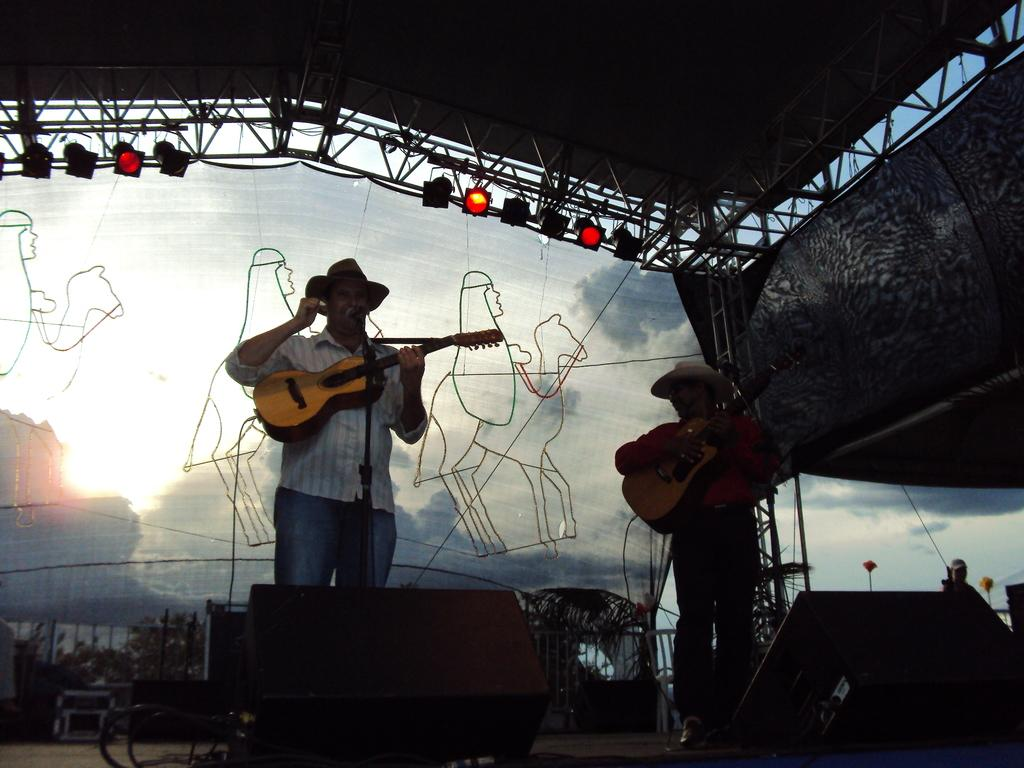How many men are present in the image? There are two men in the image. What are the men holding in the image? Both men are holding guitars. What object is placed in front of the men? There is a microphone in front of the men. What is the digestion process of the guitars in the image? Guitars do not undergo a digestion process, as they are musical instruments and not living organisms. Can you tell me the development stage of the dad in the image? There is no dad present in the image, and therefore no development stage can be determined. 